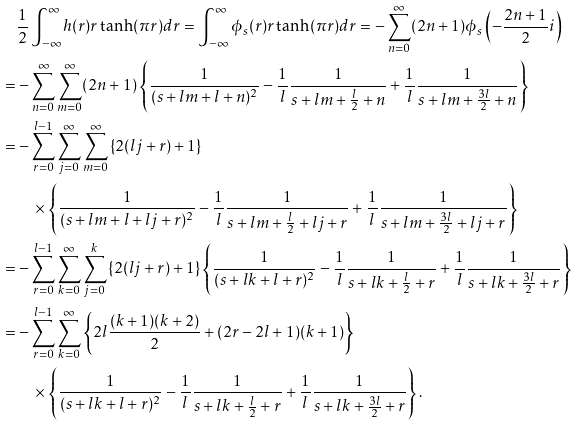Convert formula to latex. <formula><loc_0><loc_0><loc_500><loc_500>& \frac { 1 } { 2 } \int _ { - \infty } ^ { \infty } h ( r ) r \tanh ( \pi r ) d r = \int _ { - \infty } ^ { \infty } \phi _ { s } ( r ) r \tanh ( \pi r ) d r = - \sum _ { n = 0 } ^ { \infty } ( 2 n + 1 ) \phi _ { s } \left ( - \frac { 2 n + 1 } { 2 } i \right ) \\ = & - \sum _ { n = 0 } ^ { \infty } \sum _ { m = 0 } ^ { \infty } ( 2 n + 1 ) \left \{ \frac { 1 } { ( s + l m + l + n ) ^ { 2 } } - \frac { 1 } { l } \frac { 1 } { s + l m + \frac { l } { 2 } + n } + \frac { 1 } { l } \frac { 1 } { s + l m + \frac { 3 l } { 2 } + n } \right \} \\ = & - \sum _ { r = 0 } ^ { l - 1 } \sum _ { j = 0 } ^ { \infty } \sum _ { m = 0 } ^ { \infty } \left \{ 2 ( l j + r ) + 1 \right \} \\ & \quad \times \left \{ \frac { 1 } { ( s + l m + l + l j + r ) ^ { 2 } } - \frac { 1 } { l } \frac { 1 } { s + l m + \frac { l } { 2 } + l j + r } + \frac { 1 } { l } \frac { 1 } { s + l m + \frac { 3 l } { 2 } + l j + r } \right \} \\ = & - \sum _ { r = 0 } ^ { l - 1 } \sum _ { k = 0 } ^ { \infty } \sum _ { j = 0 } ^ { k } \left \{ 2 ( l j + r ) + 1 \right \} \left \{ \frac { 1 } { ( s + l k + l + r ) ^ { 2 } } - \frac { 1 } { l } \frac { 1 } { s + l k + \frac { l } { 2 } + r } + \frac { 1 } { l } \frac { 1 } { s + l k + \frac { 3 l } { 2 } + r } \right \} \\ = & - \sum _ { r = 0 } ^ { l - 1 } \sum _ { k = 0 } ^ { \infty } \left \{ 2 l \frac { ( k + 1 ) ( k + 2 ) } { 2 } + ( 2 r - 2 l + 1 ) ( k + 1 ) \right \} \\ & \quad \times \left \{ \frac { 1 } { ( s + l k + l + r ) ^ { 2 } } - \frac { 1 } { l } \frac { 1 } { s + l k + \frac { l } { 2 } + r } + \frac { 1 } { l } \frac { 1 } { s + l k + \frac { 3 l } { 2 } + r } \right \} .</formula> 